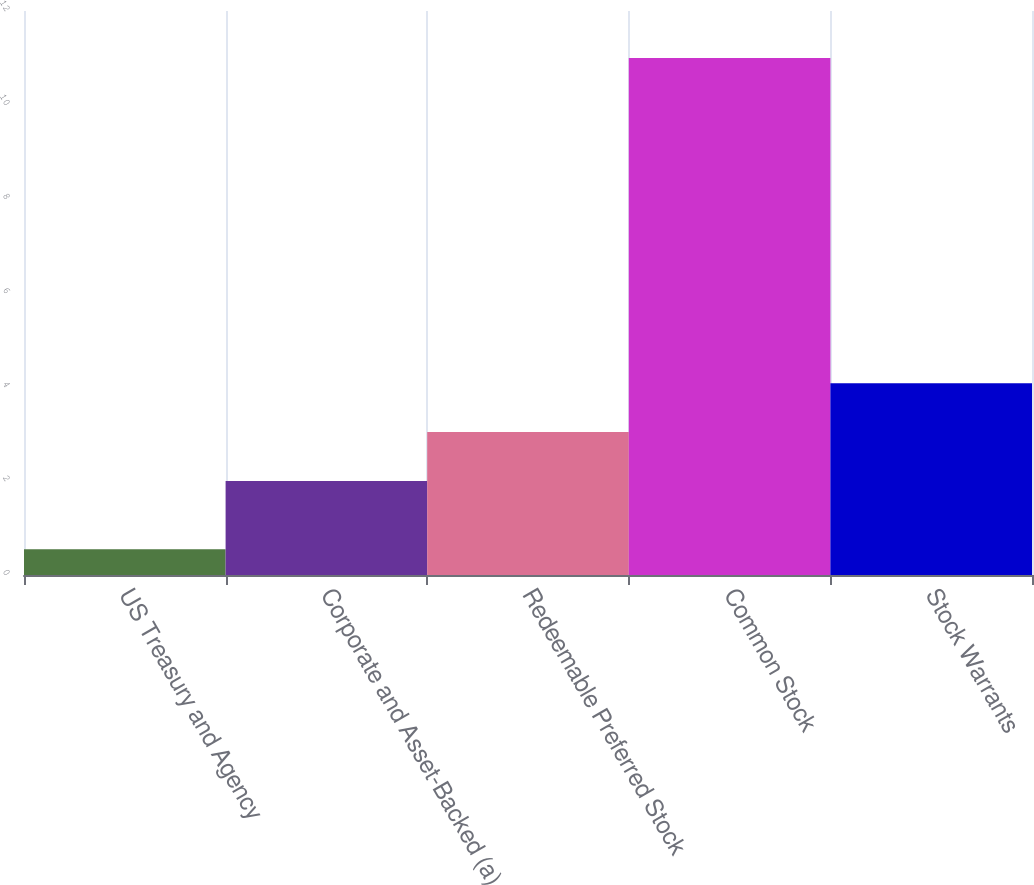<chart> <loc_0><loc_0><loc_500><loc_500><bar_chart><fcel>US Treasury and Agency<fcel>Corporate and Asset-Backed (a)<fcel>Redeemable Preferred Stock<fcel>Common Stock<fcel>Stock Warrants<nl><fcel>0.55<fcel>2<fcel>3.04<fcel>11<fcel>4.08<nl></chart> 